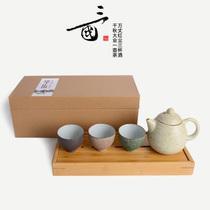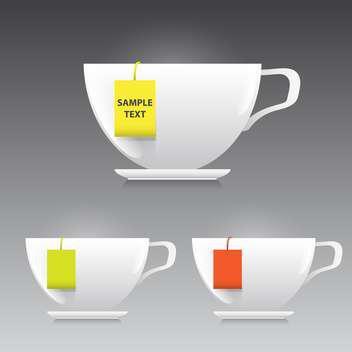The first image is the image on the left, the second image is the image on the right. For the images displayed, is the sentence "There are exactly three cups in each image in the pair." factually correct? Answer yes or no. Yes. 